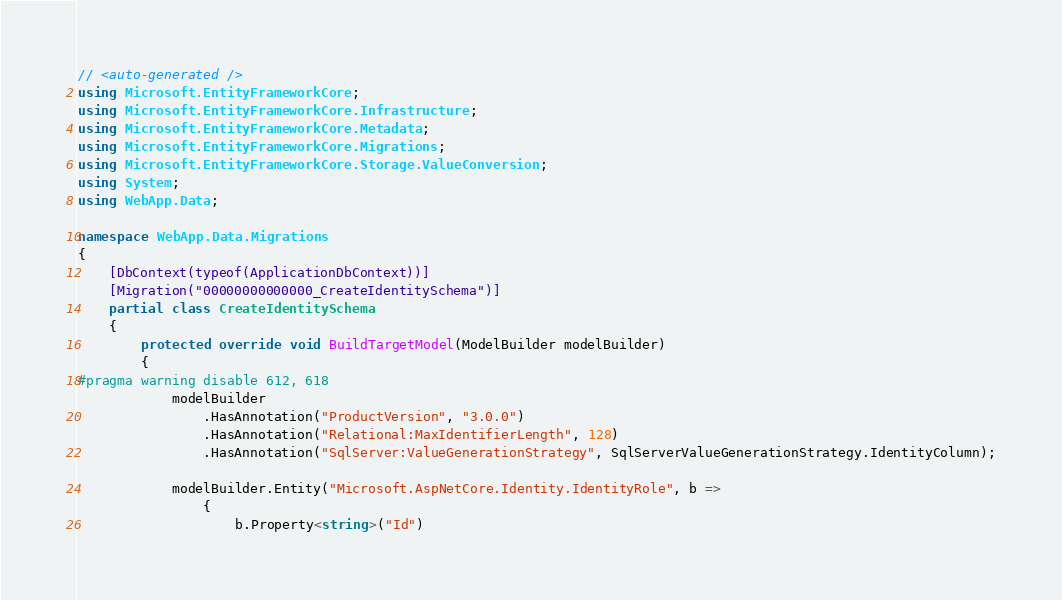Convert code to text. <code><loc_0><loc_0><loc_500><loc_500><_C#_>// <auto-generated />
using Microsoft.EntityFrameworkCore;
using Microsoft.EntityFrameworkCore.Infrastructure;
using Microsoft.EntityFrameworkCore.Metadata;
using Microsoft.EntityFrameworkCore.Migrations;
using Microsoft.EntityFrameworkCore.Storage.ValueConversion;
using System;
using WebApp.Data;

namespace WebApp.Data.Migrations
{
    [DbContext(typeof(ApplicationDbContext))]
    [Migration("00000000000000_CreateIdentitySchema")]
    partial class CreateIdentitySchema
    {
        protected override void BuildTargetModel(ModelBuilder modelBuilder)
        {
#pragma warning disable 612, 618
            modelBuilder
                .HasAnnotation("ProductVersion", "3.0.0")
                .HasAnnotation("Relational:MaxIdentifierLength", 128)
                .HasAnnotation("SqlServer:ValueGenerationStrategy", SqlServerValueGenerationStrategy.IdentityColumn);

            modelBuilder.Entity("Microsoft.AspNetCore.Identity.IdentityRole", b =>
                {
                    b.Property<string>("Id")</code> 